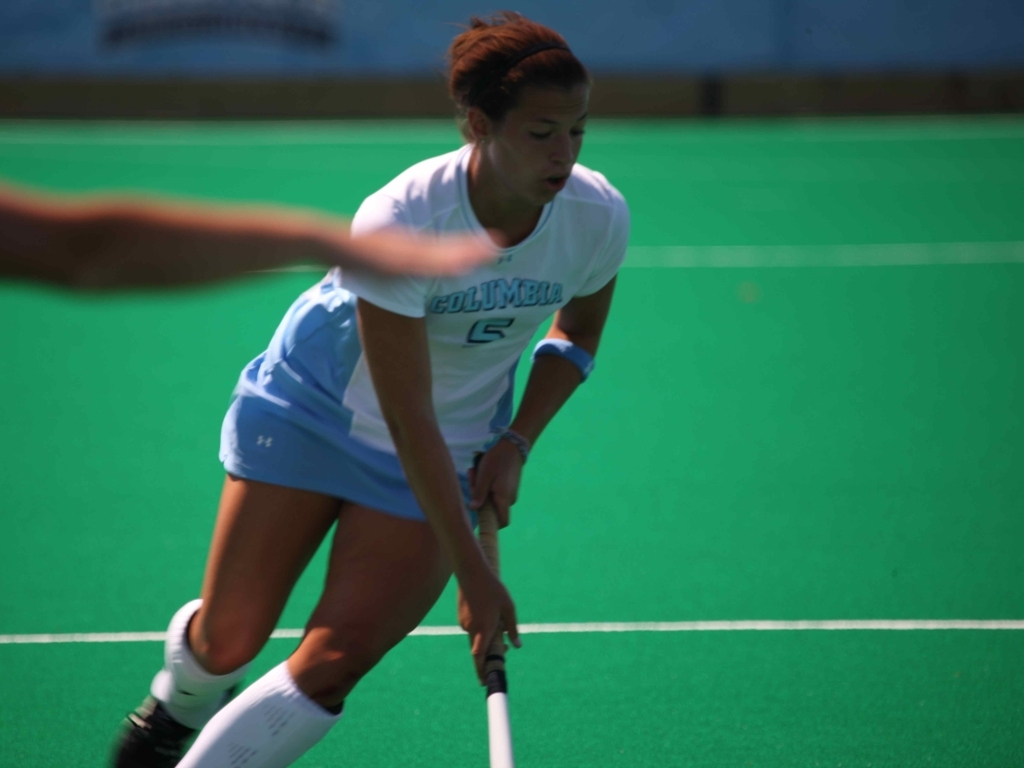What team is the player representing, based on the visible uniform? The player is representing Columbia, as indicated by the word 'COLUMBIA' on her jersey. The uniform is primarily white with light blue elements, matching the team's colors. 